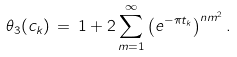Convert formula to latex. <formula><loc_0><loc_0><loc_500><loc_500>\theta _ { 3 } ( c _ { k } ) \, = \, 1 + 2 \sum _ { m = 1 } ^ { \infty } { \left ( e ^ { - \pi t _ { k } } \right ) } ^ { n m ^ { 2 } } \, .</formula> 